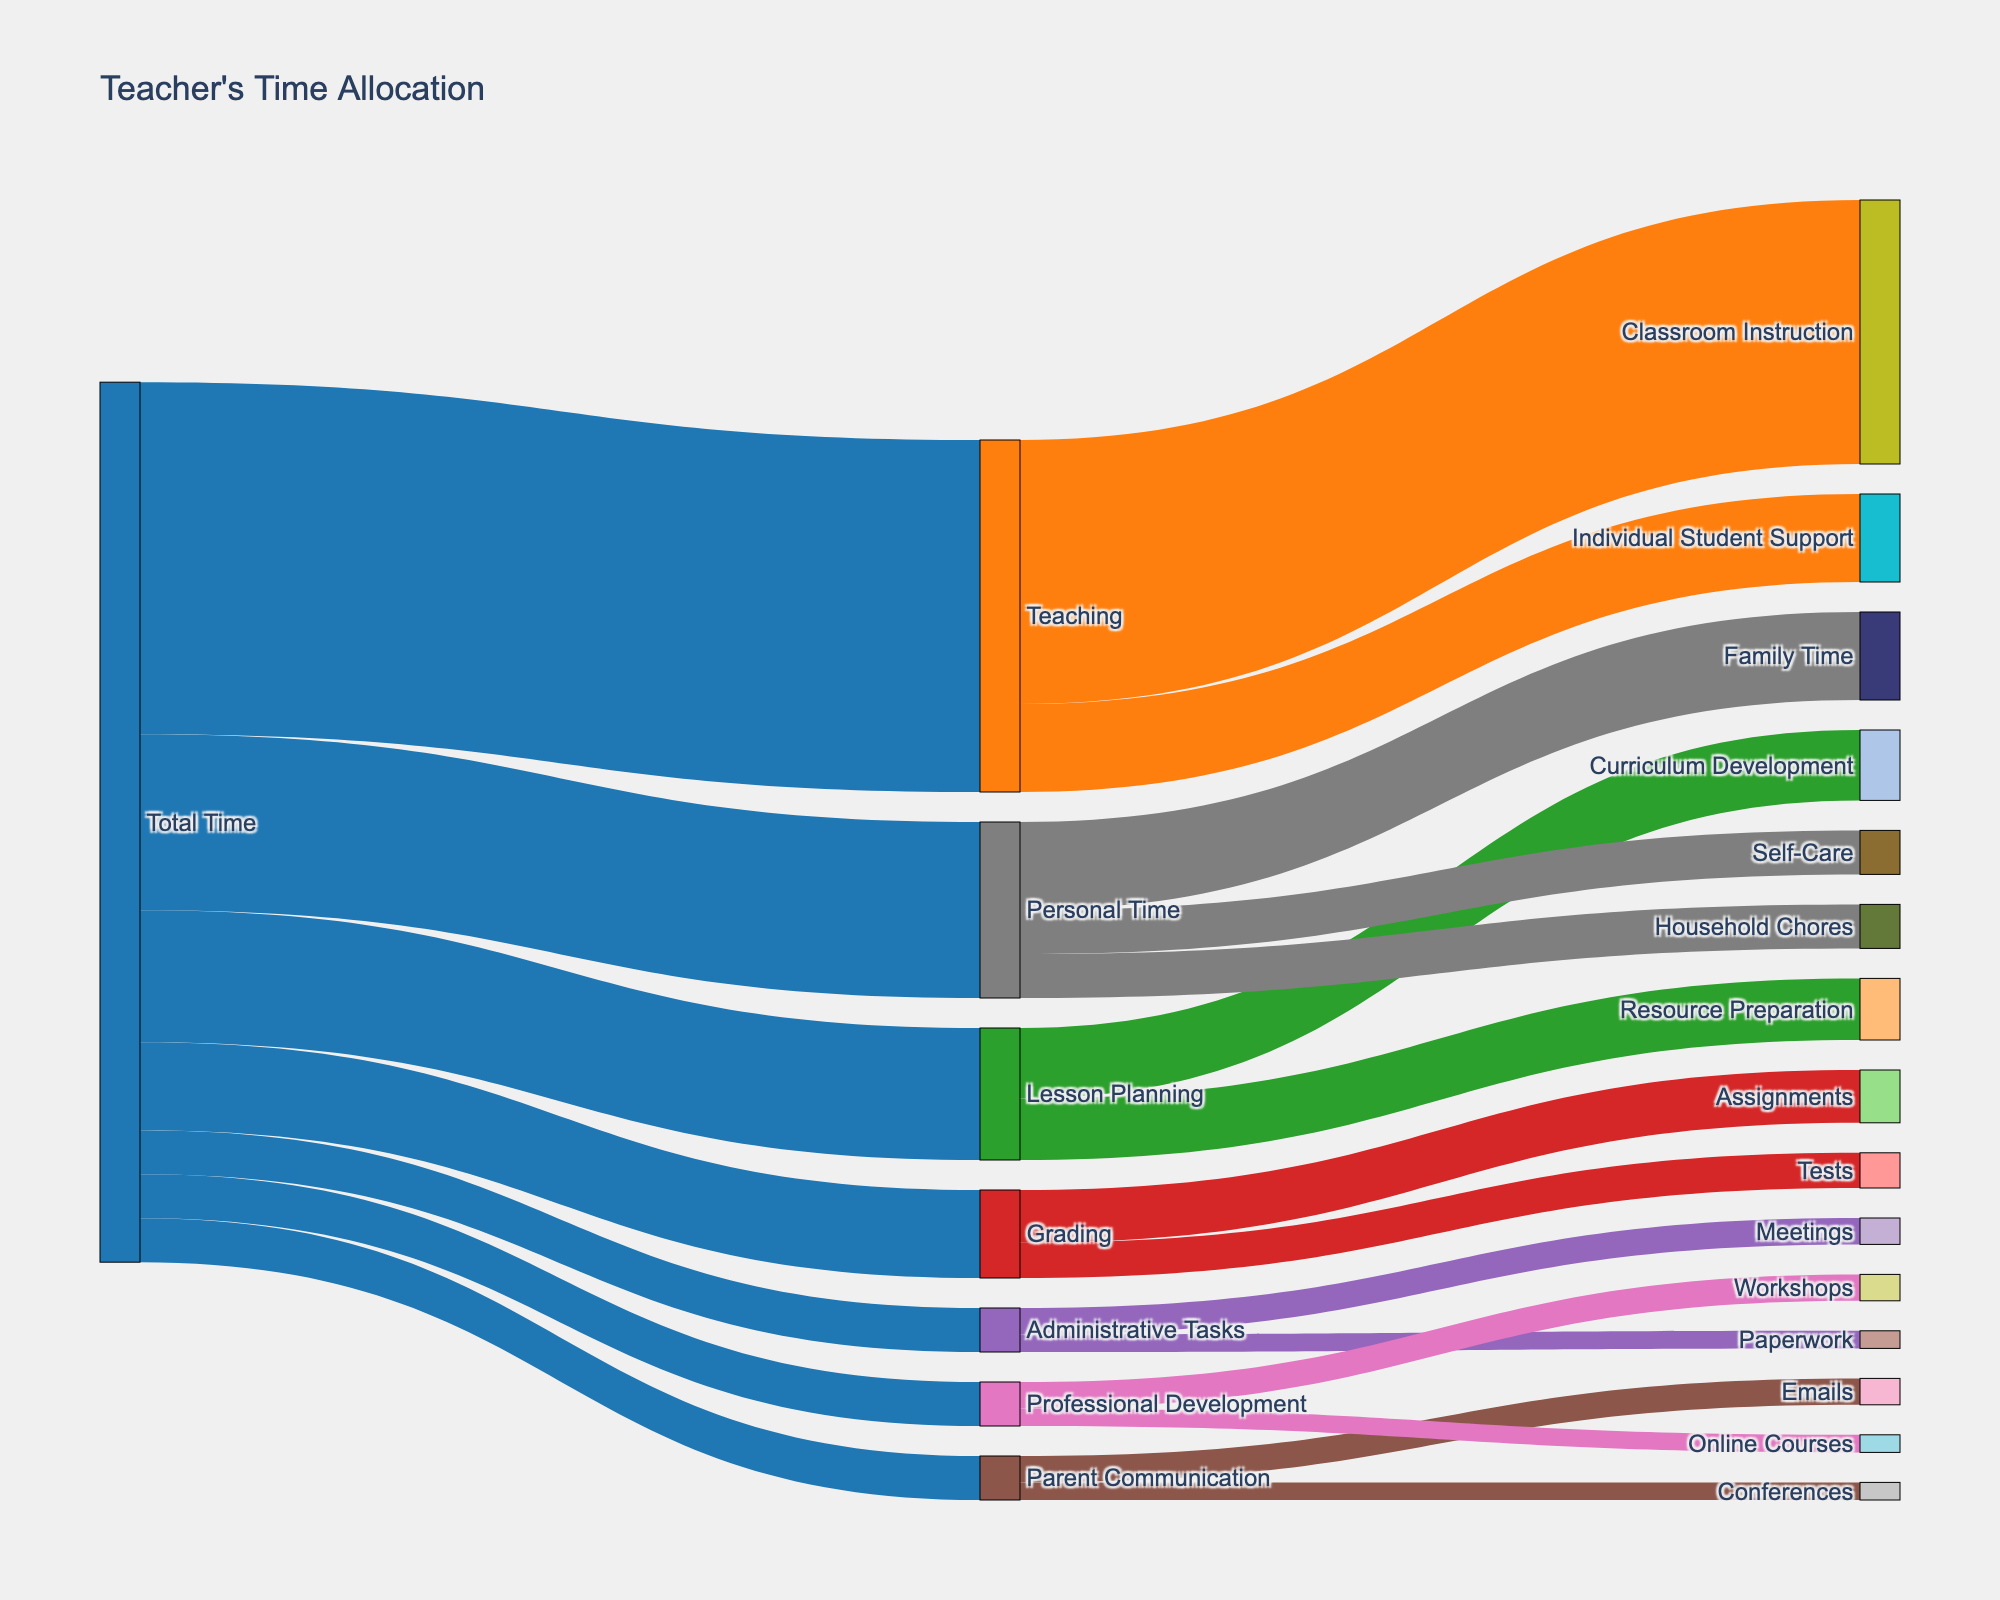What's the title of the figure? The title is usually displayed at the top of the figure. In this case, it states "Teacher's Time Allocation".
Answer: Teacher's Time Allocation How much total time is allocated to Teaching? Look at the link value that connects the "Total Time" node to the "Teaching" node. The value listed is 40.
Answer: 40 What activities fall under "Lesson Planning" and how is the time distributed among them? Identify the target nodes connected to "Lesson Planning". The time allocation is "Curriculum Development" (8) and "Resource Preparation" (7).
Answer: Curriculum Development: 8, Resource Preparation: 7 Which activity under "Personal Time" has the least allocation? Examine the activities under "Personal Time": "Family Time" (10), "Household Chores" (5), and "Self-Care" (5). The least allocation is a tie between "Household Chores" and "Self-Care", each with 5.
Answer: Household Chores, Self-Care What is the total time allocated to student's learning activities under "Teaching"? Look at the time allotted to both "Classroom Instruction" (30) and "Individual Student Support" (10) under "Teaching". Sum these values: 30 + 10 = 40.
Answer: 40 Which category has the highest time allocation? Identify the category (Teaching, Lesson Planning, Grading, Administrative Tasks, Parent Communication, Professional Development, Personal Time) with the highest value directly linked to "Total Time". "Teaching" has the highest allocation with 40.
Answer: Teaching Compare the time spent on "Emails" and "Conferences" under "Parent Communication". Which one takes more time? Look for the values connected to "Parent Communication". "Emails" has 3 and "Conferences" has 2. "Emails" takes more time.
Answer: Emails How much time in total is dedicated to "Administrative Tasks"? Sum the time allocated to "Meetings" (3) and "Paperwork" (2) under "Administrative Tasks": 3 + 2 = 5.
Answer: 5 What percentage of "Total Time" is given to "Professional Development"? Divide the time allocated to Professional Development (5) by the "Total Time" and multiply by 100: (5 / 100) * 100% = 5%.
Answer: 5% What is the difference in time allocation between "Grading" and "Parent Communication"? Subtract the time allocated to "Parent Communication" (5) from "Grading" (10): 10 - 5 = 5.
Answer: 5 